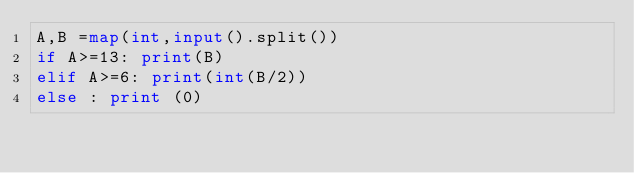Convert code to text. <code><loc_0><loc_0><loc_500><loc_500><_Python_>A,B =map(int,input().split())
if A>=13: print(B)
elif A>=6: print(int(B/2))
else : print (0)</code> 